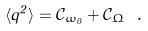Convert formula to latex. <formula><loc_0><loc_0><loc_500><loc_500>\langle q ^ { 2 } \rangle = \mathcal { C } _ { \omega _ { 0 } } + \mathcal { C } _ { \Omega } \ .</formula> 